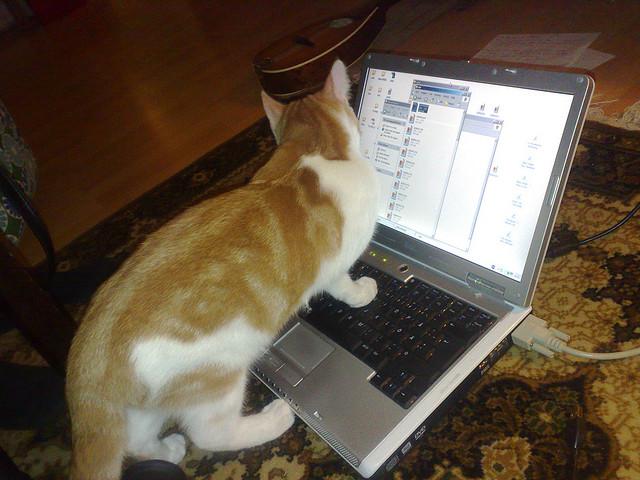What is the laptop on?
Short answer required. Floor. What kind of animal is this?
Be succinct. Cat. What color is the cat?
Be succinct. Orange. Why is the cat on the laptop?
Be succinct. Curious. 